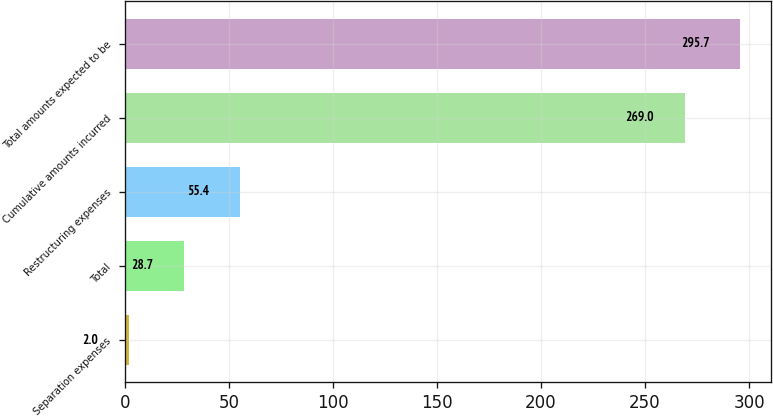Convert chart. <chart><loc_0><loc_0><loc_500><loc_500><bar_chart><fcel>Separation expenses<fcel>Total<fcel>Restructuring expenses<fcel>Cumulative amounts incurred<fcel>Total amounts expected to be<nl><fcel>2<fcel>28.7<fcel>55.4<fcel>269<fcel>295.7<nl></chart> 